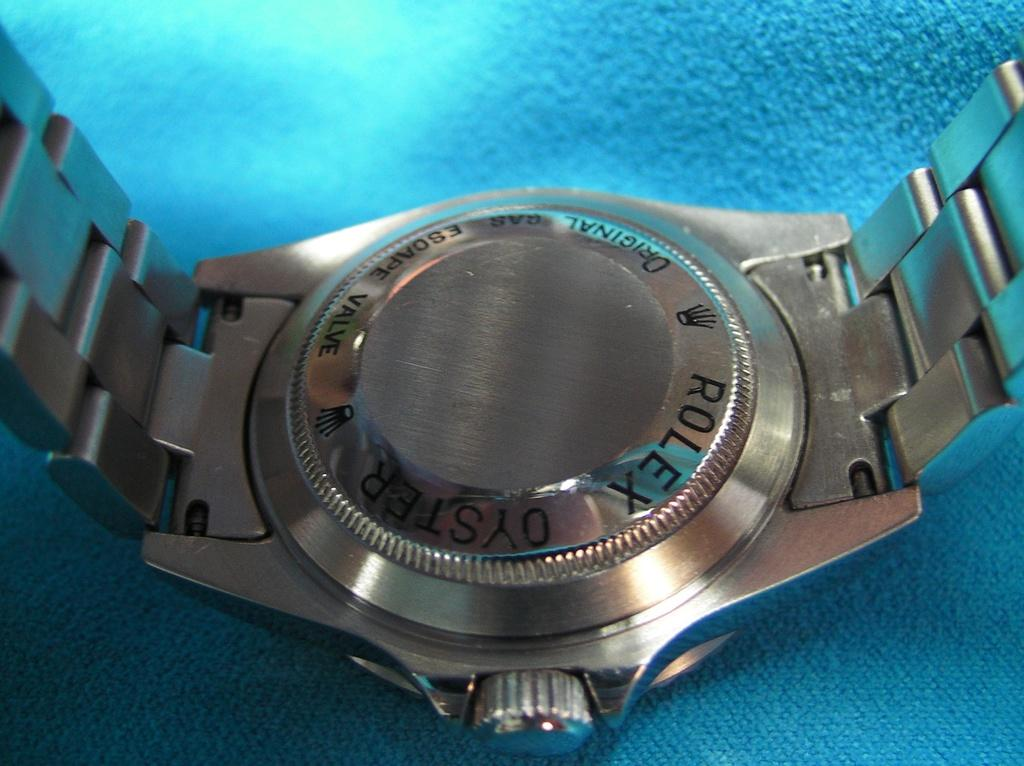<image>
Present a compact description of the photo's key features. Silver watch with the word ROLEX on the back. 